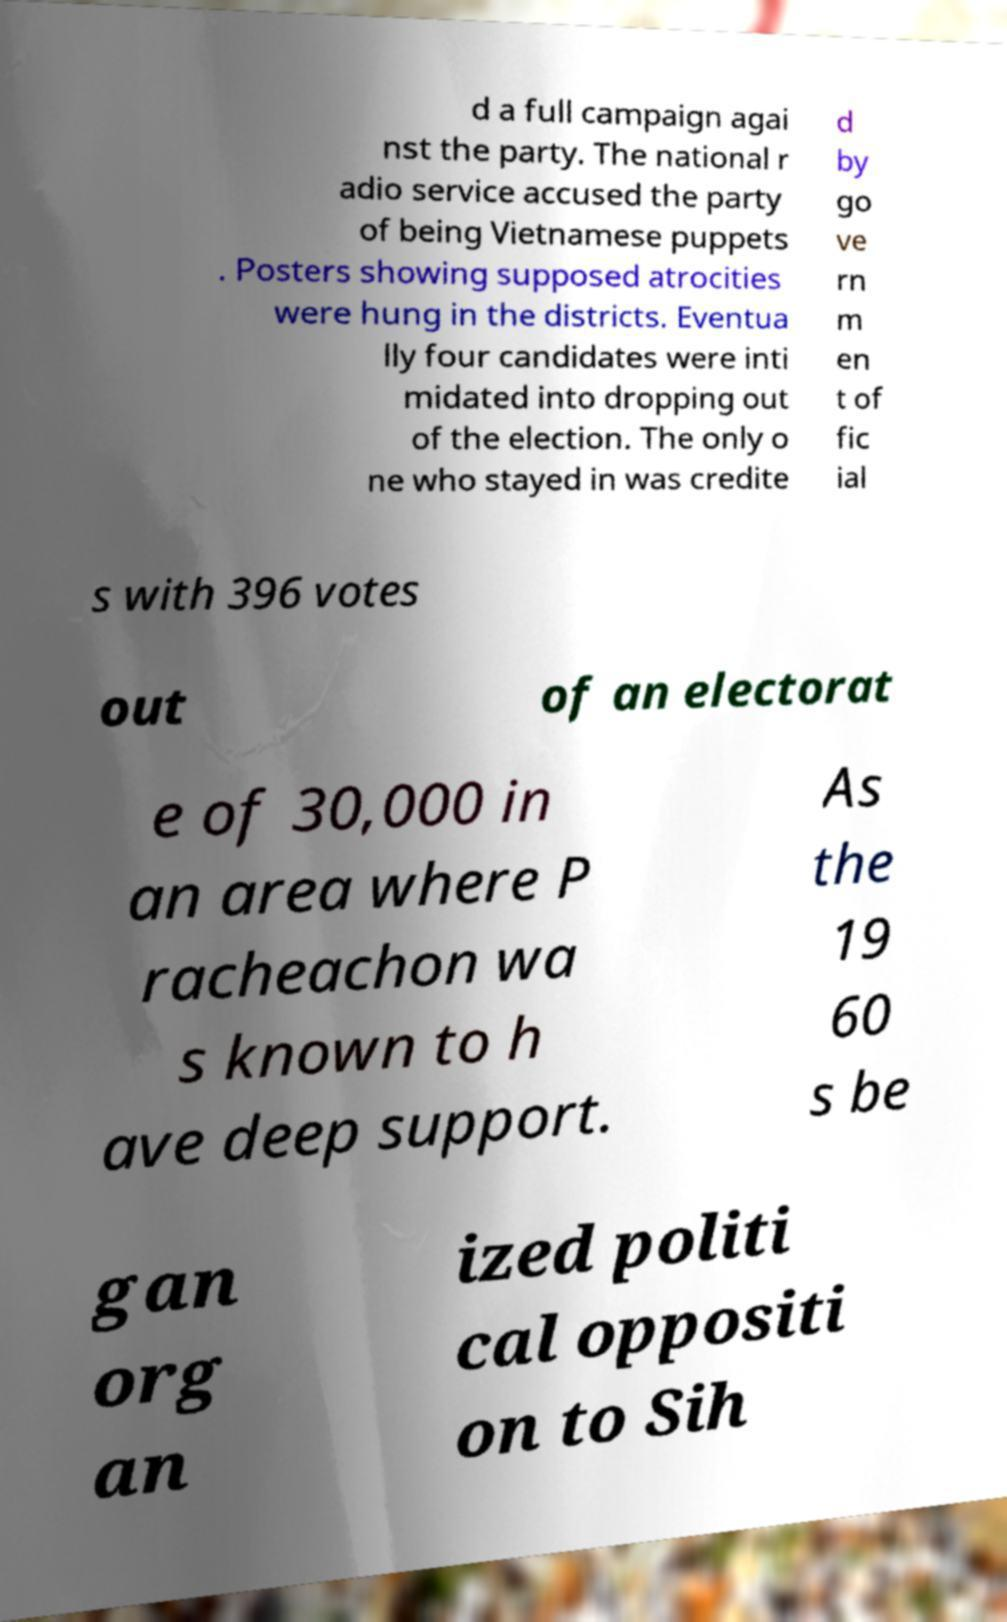Could you extract and type out the text from this image? d a full campaign agai nst the party. The national r adio service accused the party of being Vietnamese puppets . Posters showing supposed atrocities were hung in the districts. Eventua lly four candidates were inti midated into dropping out of the election. The only o ne who stayed in was credite d by go ve rn m en t of fic ial s with 396 votes out of an electorat e of 30,000 in an area where P racheachon wa s known to h ave deep support. As the 19 60 s be gan org an ized politi cal oppositi on to Sih 